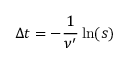Convert formula to latex. <formula><loc_0><loc_0><loc_500><loc_500>\Delta t = - \frac { 1 } { \nu ^ { \prime } } \ln ( s )</formula> 